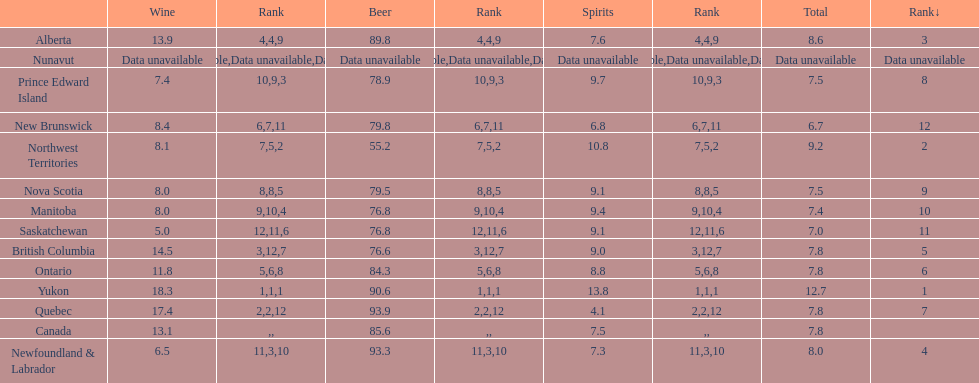Who drank more beer, quebec or northwest territories? Quebec. 